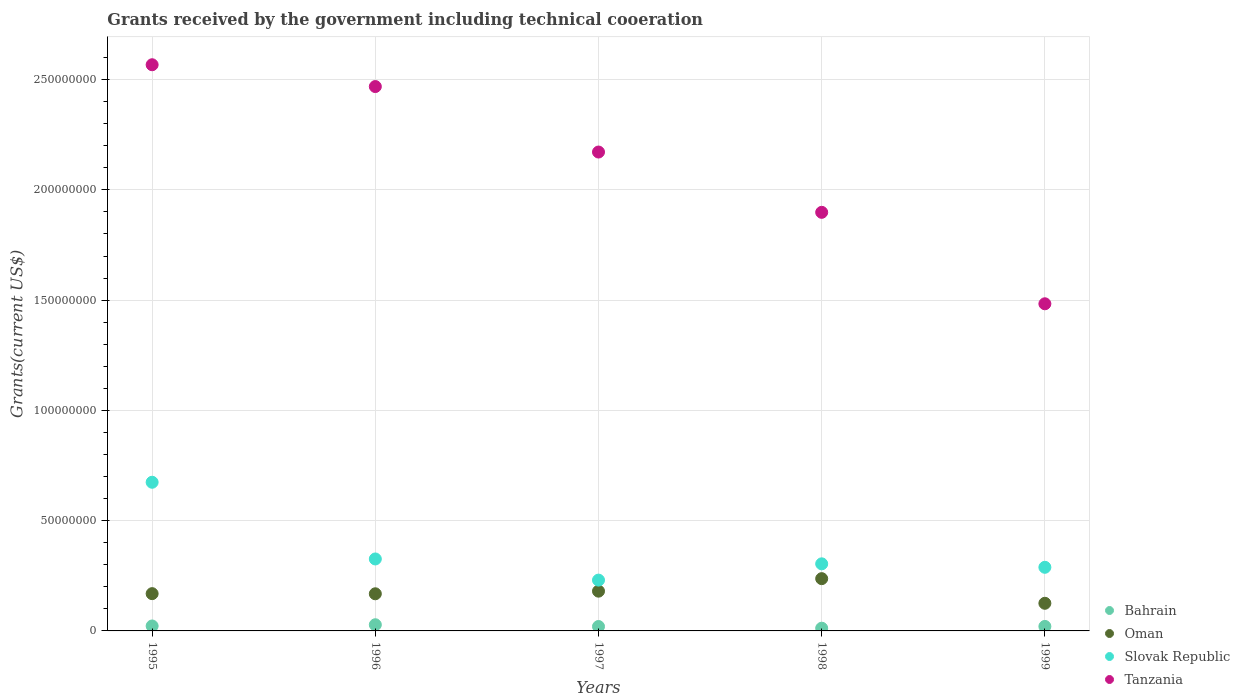Is the number of dotlines equal to the number of legend labels?
Offer a terse response. Yes. What is the total grants received by the government in Bahrain in 1996?
Provide a succinct answer. 2.80e+06. Across all years, what is the maximum total grants received by the government in Tanzania?
Keep it short and to the point. 2.57e+08. Across all years, what is the minimum total grants received by the government in Slovak Republic?
Offer a terse response. 2.30e+07. What is the total total grants received by the government in Tanzania in the graph?
Keep it short and to the point. 1.06e+09. What is the difference between the total grants received by the government in Slovak Republic in 1995 and that in 1999?
Make the answer very short. 3.86e+07. What is the difference between the total grants received by the government in Oman in 1998 and the total grants received by the government in Slovak Republic in 1999?
Provide a short and direct response. -5.15e+06. What is the average total grants received by the government in Oman per year?
Provide a succinct answer. 1.76e+07. In the year 1997, what is the difference between the total grants received by the government in Bahrain and total grants received by the government in Oman?
Your response must be concise. -1.60e+07. What is the ratio of the total grants received by the government in Oman in 1995 to that in 1998?
Your response must be concise. 0.71. Is the total grants received by the government in Slovak Republic in 1996 less than that in 1998?
Your answer should be compact. No. Is the difference between the total grants received by the government in Bahrain in 1996 and 1999 greater than the difference between the total grants received by the government in Oman in 1996 and 1999?
Keep it short and to the point. No. What is the difference between the highest and the second highest total grants received by the government in Tanzania?
Offer a very short reply. 9.89e+06. What is the difference between the highest and the lowest total grants received by the government in Slovak Republic?
Offer a very short reply. 4.44e+07. Is it the case that in every year, the sum of the total grants received by the government in Bahrain and total grants received by the government in Slovak Republic  is greater than the sum of total grants received by the government in Oman and total grants received by the government in Tanzania?
Offer a very short reply. No. Is it the case that in every year, the sum of the total grants received by the government in Oman and total grants received by the government in Slovak Republic  is greater than the total grants received by the government in Tanzania?
Offer a terse response. No. Is the total grants received by the government in Oman strictly less than the total grants received by the government in Slovak Republic over the years?
Offer a very short reply. Yes. How many years are there in the graph?
Keep it short and to the point. 5. Does the graph contain grids?
Provide a short and direct response. Yes. How many legend labels are there?
Your response must be concise. 4. How are the legend labels stacked?
Keep it short and to the point. Vertical. What is the title of the graph?
Provide a succinct answer. Grants received by the government including technical cooeration. What is the label or title of the Y-axis?
Provide a succinct answer. Grants(current US$). What is the Grants(current US$) of Bahrain in 1995?
Keep it short and to the point. 2.24e+06. What is the Grants(current US$) of Oman in 1995?
Give a very brief answer. 1.69e+07. What is the Grants(current US$) of Slovak Republic in 1995?
Make the answer very short. 6.74e+07. What is the Grants(current US$) in Tanzania in 1995?
Your answer should be very brief. 2.57e+08. What is the Grants(current US$) in Bahrain in 1996?
Provide a succinct answer. 2.80e+06. What is the Grants(current US$) of Oman in 1996?
Your answer should be very brief. 1.68e+07. What is the Grants(current US$) of Slovak Republic in 1996?
Ensure brevity in your answer.  3.26e+07. What is the Grants(current US$) in Tanzania in 1996?
Keep it short and to the point. 2.47e+08. What is the Grants(current US$) in Bahrain in 1997?
Keep it short and to the point. 2.00e+06. What is the Grants(current US$) of Oman in 1997?
Ensure brevity in your answer.  1.80e+07. What is the Grants(current US$) in Slovak Republic in 1997?
Keep it short and to the point. 2.30e+07. What is the Grants(current US$) of Tanzania in 1997?
Give a very brief answer. 2.17e+08. What is the Grants(current US$) of Bahrain in 1998?
Make the answer very short. 1.23e+06. What is the Grants(current US$) in Oman in 1998?
Your response must be concise. 2.37e+07. What is the Grants(current US$) in Slovak Republic in 1998?
Provide a short and direct response. 3.04e+07. What is the Grants(current US$) of Tanzania in 1998?
Offer a terse response. 1.90e+08. What is the Grants(current US$) of Bahrain in 1999?
Provide a succinct answer. 2.04e+06. What is the Grants(current US$) in Oman in 1999?
Provide a short and direct response. 1.25e+07. What is the Grants(current US$) in Slovak Republic in 1999?
Keep it short and to the point. 2.88e+07. What is the Grants(current US$) in Tanzania in 1999?
Ensure brevity in your answer.  1.48e+08. Across all years, what is the maximum Grants(current US$) of Bahrain?
Give a very brief answer. 2.80e+06. Across all years, what is the maximum Grants(current US$) of Oman?
Provide a short and direct response. 2.37e+07. Across all years, what is the maximum Grants(current US$) in Slovak Republic?
Ensure brevity in your answer.  6.74e+07. Across all years, what is the maximum Grants(current US$) of Tanzania?
Provide a succinct answer. 2.57e+08. Across all years, what is the minimum Grants(current US$) of Bahrain?
Your answer should be compact. 1.23e+06. Across all years, what is the minimum Grants(current US$) of Oman?
Give a very brief answer. 1.25e+07. Across all years, what is the minimum Grants(current US$) of Slovak Republic?
Ensure brevity in your answer.  2.30e+07. Across all years, what is the minimum Grants(current US$) of Tanzania?
Ensure brevity in your answer.  1.48e+08. What is the total Grants(current US$) of Bahrain in the graph?
Your response must be concise. 1.03e+07. What is the total Grants(current US$) in Oman in the graph?
Your answer should be very brief. 8.80e+07. What is the total Grants(current US$) of Slovak Republic in the graph?
Make the answer very short. 1.82e+08. What is the total Grants(current US$) of Tanzania in the graph?
Provide a short and direct response. 1.06e+09. What is the difference between the Grants(current US$) in Bahrain in 1995 and that in 1996?
Offer a terse response. -5.60e+05. What is the difference between the Grants(current US$) of Slovak Republic in 1995 and that in 1996?
Offer a very short reply. 3.48e+07. What is the difference between the Grants(current US$) of Tanzania in 1995 and that in 1996?
Make the answer very short. 9.89e+06. What is the difference between the Grants(current US$) of Bahrain in 1995 and that in 1997?
Provide a short and direct response. 2.40e+05. What is the difference between the Grants(current US$) in Oman in 1995 and that in 1997?
Keep it short and to the point. -1.13e+06. What is the difference between the Grants(current US$) in Slovak Republic in 1995 and that in 1997?
Offer a very short reply. 4.44e+07. What is the difference between the Grants(current US$) of Tanzania in 1995 and that in 1997?
Your answer should be very brief. 3.96e+07. What is the difference between the Grants(current US$) in Bahrain in 1995 and that in 1998?
Provide a short and direct response. 1.01e+06. What is the difference between the Grants(current US$) in Oman in 1995 and that in 1998?
Your answer should be compact. -6.80e+06. What is the difference between the Grants(current US$) in Slovak Republic in 1995 and that in 1998?
Offer a terse response. 3.70e+07. What is the difference between the Grants(current US$) in Tanzania in 1995 and that in 1998?
Make the answer very short. 6.69e+07. What is the difference between the Grants(current US$) of Oman in 1995 and that in 1999?
Give a very brief answer. 4.37e+06. What is the difference between the Grants(current US$) of Slovak Republic in 1995 and that in 1999?
Offer a very short reply. 3.86e+07. What is the difference between the Grants(current US$) in Tanzania in 1995 and that in 1999?
Provide a succinct answer. 1.08e+08. What is the difference between the Grants(current US$) of Oman in 1996 and that in 1997?
Give a very brief answer. -1.19e+06. What is the difference between the Grants(current US$) of Slovak Republic in 1996 and that in 1997?
Provide a short and direct response. 9.59e+06. What is the difference between the Grants(current US$) in Tanzania in 1996 and that in 1997?
Your response must be concise. 2.97e+07. What is the difference between the Grants(current US$) of Bahrain in 1996 and that in 1998?
Offer a terse response. 1.57e+06. What is the difference between the Grants(current US$) in Oman in 1996 and that in 1998?
Offer a very short reply. -6.86e+06. What is the difference between the Grants(current US$) of Slovak Republic in 1996 and that in 1998?
Make the answer very short. 2.21e+06. What is the difference between the Grants(current US$) in Tanzania in 1996 and that in 1998?
Provide a short and direct response. 5.70e+07. What is the difference between the Grants(current US$) in Bahrain in 1996 and that in 1999?
Your answer should be compact. 7.60e+05. What is the difference between the Grants(current US$) in Oman in 1996 and that in 1999?
Make the answer very short. 4.31e+06. What is the difference between the Grants(current US$) in Slovak Republic in 1996 and that in 1999?
Provide a succinct answer. 3.78e+06. What is the difference between the Grants(current US$) in Tanzania in 1996 and that in 1999?
Keep it short and to the point. 9.85e+07. What is the difference between the Grants(current US$) of Bahrain in 1997 and that in 1998?
Offer a terse response. 7.70e+05. What is the difference between the Grants(current US$) in Oman in 1997 and that in 1998?
Ensure brevity in your answer.  -5.67e+06. What is the difference between the Grants(current US$) of Slovak Republic in 1997 and that in 1998?
Offer a very short reply. -7.38e+06. What is the difference between the Grants(current US$) in Tanzania in 1997 and that in 1998?
Provide a succinct answer. 2.73e+07. What is the difference between the Grants(current US$) in Oman in 1997 and that in 1999?
Your response must be concise. 5.50e+06. What is the difference between the Grants(current US$) of Slovak Republic in 1997 and that in 1999?
Ensure brevity in your answer.  -5.81e+06. What is the difference between the Grants(current US$) in Tanzania in 1997 and that in 1999?
Your response must be concise. 6.88e+07. What is the difference between the Grants(current US$) of Bahrain in 1998 and that in 1999?
Your answer should be compact. -8.10e+05. What is the difference between the Grants(current US$) in Oman in 1998 and that in 1999?
Give a very brief answer. 1.12e+07. What is the difference between the Grants(current US$) of Slovak Republic in 1998 and that in 1999?
Provide a succinct answer. 1.57e+06. What is the difference between the Grants(current US$) of Tanzania in 1998 and that in 1999?
Give a very brief answer. 4.15e+07. What is the difference between the Grants(current US$) of Bahrain in 1995 and the Grants(current US$) of Oman in 1996?
Make the answer very short. -1.46e+07. What is the difference between the Grants(current US$) of Bahrain in 1995 and the Grants(current US$) of Slovak Republic in 1996?
Make the answer very short. -3.04e+07. What is the difference between the Grants(current US$) in Bahrain in 1995 and the Grants(current US$) in Tanzania in 1996?
Your answer should be very brief. -2.45e+08. What is the difference between the Grants(current US$) in Oman in 1995 and the Grants(current US$) in Slovak Republic in 1996?
Offer a terse response. -1.57e+07. What is the difference between the Grants(current US$) in Oman in 1995 and the Grants(current US$) in Tanzania in 1996?
Give a very brief answer. -2.30e+08. What is the difference between the Grants(current US$) in Slovak Republic in 1995 and the Grants(current US$) in Tanzania in 1996?
Keep it short and to the point. -1.79e+08. What is the difference between the Grants(current US$) of Bahrain in 1995 and the Grants(current US$) of Oman in 1997?
Provide a succinct answer. -1.58e+07. What is the difference between the Grants(current US$) in Bahrain in 1995 and the Grants(current US$) in Slovak Republic in 1997?
Ensure brevity in your answer.  -2.08e+07. What is the difference between the Grants(current US$) of Bahrain in 1995 and the Grants(current US$) of Tanzania in 1997?
Your answer should be compact. -2.15e+08. What is the difference between the Grants(current US$) of Oman in 1995 and the Grants(current US$) of Slovak Republic in 1997?
Keep it short and to the point. -6.14e+06. What is the difference between the Grants(current US$) in Oman in 1995 and the Grants(current US$) in Tanzania in 1997?
Offer a terse response. -2.00e+08. What is the difference between the Grants(current US$) in Slovak Republic in 1995 and the Grants(current US$) in Tanzania in 1997?
Give a very brief answer. -1.50e+08. What is the difference between the Grants(current US$) in Bahrain in 1995 and the Grants(current US$) in Oman in 1998?
Your answer should be very brief. -2.15e+07. What is the difference between the Grants(current US$) of Bahrain in 1995 and the Grants(current US$) of Slovak Republic in 1998?
Your answer should be compact. -2.82e+07. What is the difference between the Grants(current US$) in Bahrain in 1995 and the Grants(current US$) in Tanzania in 1998?
Your answer should be very brief. -1.88e+08. What is the difference between the Grants(current US$) of Oman in 1995 and the Grants(current US$) of Slovak Republic in 1998?
Provide a succinct answer. -1.35e+07. What is the difference between the Grants(current US$) in Oman in 1995 and the Grants(current US$) in Tanzania in 1998?
Ensure brevity in your answer.  -1.73e+08. What is the difference between the Grants(current US$) of Slovak Republic in 1995 and the Grants(current US$) of Tanzania in 1998?
Provide a succinct answer. -1.22e+08. What is the difference between the Grants(current US$) of Bahrain in 1995 and the Grants(current US$) of Oman in 1999?
Your response must be concise. -1.03e+07. What is the difference between the Grants(current US$) in Bahrain in 1995 and the Grants(current US$) in Slovak Republic in 1999?
Offer a terse response. -2.66e+07. What is the difference between the Grants(current US$) of Bahrain in 1995 and the Grants(current US$) of Tanzania in 1999?
Offer a terse response. -1.46e+08. What is the difference between the Grants(current US$) of Oman in 1995 and the Grants(current US$) of Slovak Republic in 1999?
Keep it short and to the point. -1.20e+07. What is the difference between the Grants(current US$) of Oman in 1995 and the Grants(current US$) of Tanzania in 1999?
Provide a succinct answer. -1.31e+08. What is the difference between the Grants(current US$) in Slovak Republic in 1995 and the Grants(current US$) in Tanzania in 1999?
Provide a succinct answer. -8.09e+07. What is the difference between the Grants(current US$) of Bahrain in 1996 and the Grants(current US$) of Oman in 1997?
Make the answer very short. -1.52e+07. What is the difference between the Grants(current US$) in Bahrain in 1996 and the Grants(current US$) in Slovak Republic in 1997?
Ensure brevity in your answer.  -2.02e+07. What is the difference between the Grants(current US$) of Bahrain in 1996 and the Grants(current US$) of Tanzania in 1997?
Give a very brief answer. -2.14e+08. What is the difference between the Grants(current US$) of Oman in 1996 and the Grants(current US$) of Slovak Republic in 1997?
Keep it short and to the point. -6.20e+06. What is the difference between the Grants(current US$) in Oman in 1996 and the Grants(current US$) in Tanzania in 1997?
Your answer should be compact. -2.00e+08. What is the difference between the Grants(current US$) in Slovak Republic in 1996 and the Grants(current US$) in Tanzania in 1997?
Keep it short and to the point. -1.85e+08. What is the difference between the Grants(current US$) of Bahrain in 1996 and the Grants(current US$) of Oman in 1998?
Your answer should be compact. -2.09e+07. What is the difference between the Grants(current US$) in Bahrain in 1996 and the Grants(current US$) in Slovak Republic in 1998?
Your response must be concise. -2.76e+07. What is the difference between the Grants(current US$) in Bahrain in 1996 and the Grants(current US$) in Tanzania in 1998?
Ensure brevity in your answer.  -1.87e+08. What is the difference between the Grants(current US$) in Oman in 1996 and the Grants(current US$) in Slovak Republic in 1998?
Keep it short and to the point. -1.36e+07. What is the difference between the Grants(current US$) in Oman in 1996 and the Grants(current US$) in Tanzania in 1998?
Offer a very short reply. -1.73e+08. What is the difference between the Grants(current US$) in Slovak Republic in 1996 and the Grants(current US$) in Tanzania in 1998?
Give a very brief answer. -1.57e+08. What is the difference between the Grants(current US$) in Bahrain in 1996 and the Grants(current US$) in Oman in 1999?
Provide a short and direct response. -9.73e+06. What is the difference between the Grants(current US$) of Bahrain in 1996 and the Grants(current US$) of Slovak Republic in 1999?
Your response must be concise. -2.60e+07. What is the difference between the Grants(current US$) in Bahrain in 1996 and the Grants(current US$) in Tanzania in 1999?
Your answer should be compact. -1.46e+08. What is the difference between the Grants(current US$) of Oman in 1996 and the Grants(current US$) of Slovak Republic in 1999?
Offer a terse response. -1.20e+07. What is the difference between the Grants(current US$) in Oman in 1996 and the Grants(current US$) in Tanzania in 1999?
Your answer should be compact. -1.32e+08. What is the difference between the Grants(current US$) of Slovak Republic in 1996 and the Grants(current US$) of Tanzania in 1999?
Offer a very short reply. -1.16e+08. What is the difference between the Grants(current US$) of Bahrain in 1997 and the Grants(current US$) of Oman in 1998?
Your response must be concise. -2.17e+07. What is the difference between the Grants(current US$) in Bahrain in 1997 and the Grants(current US$) in Slovak Republic in 1998?
Give a very brief answer. -2.84e+07. What is the difference between the Grants(current US$) in Bahrain in 1997 and the Grants(current US$) in Tanzania in 1998?
Make the answer very short. -1.88e+08. What is the difference between the Grants(current US$) in Oman in 1997 and the Grants(current US$) in Slovak Republic in 1998?
Provide a succinct answer. -1.24e+07. What is the difference between the Grants(current US$) of Oman in 1997 and the Grants(current US$) of Tanzania in 1998?
Offer a terse response. -1.72e+08. What is the difference between the Grants(current US$) of Slovak Republic in 1997 and the Grants(current US$) of Tanzania in 1998?
Give a very brief answer. -1.67e+08. What is the difference between the Grants(current US$) in Bahrain in 1997 and the Grants(current US$) in Oman in 1999?
Your answer should be very brief. -1.05e+07. What is the difference between the Grants(current US$) of Bahrain in 1997 and the Grants(current US$) of Slovak Republic in 1999?
Make the answer very short. -2.68e+07. What is the difference between the Grants(current US$) in Bahrain in 1997 and the Grants(current US$) in Tanzania in 1999?
Provide a succinct answer. -1.46e+08. What is the difference between the Grants(current US$) in Oman in 1997 and the Grants(current US$) in Slovak Republic in 1999?
Ensure brevity in your answer.  -1.08e+07. What is the difference between the Grants(current US$) of Oman in 1997 and the Grants(current US$) of Tanzania in 1999?
Your response must be concise. -1.30e+08. What is the difference between the Grants(current US$) of Slovak Republic in 1997 and the Grants(current US$) of Tanzania in 1999?
Make the answer very short. -1.25e+08. What is the difference between the Grants(current US$) of Bahrain in 1998 and the Grants(current US$) of Oman in 1999?
Your response must be concise. -1.13e+07. What is the difference between the Grants(current US$) in Bahrain in 1998 and the Grants(current US$) in Slovak Republic in 1999?
Give a very brief answer. -2.76e+07. What is the difference between the Grants(current US$) in Bahrain in 1998 and the Grants(current US$) in Tanzania in 1999?
Provide a short and direct response. -1.47e+08. What is the difference between the Grants(current US$) of Oman in 1998 and the Grants(current US$) of Slovak Republic in 1999?
Provide a short and direct response. -5.15e+06. What is the difference between the Grants(current US$) of Oman in 1998 and the Grants(current US$) of Tanzania in 1999?
Make the answer very short. -1.25e+08. What is the difference between the Grants(current US$) in Slovak Republic in 1998 and the Grants(current US$) in Tanzania in 1999?
Give a very brief answer. -1.18e+08. What is the average Grants(current US$) in Bahrain per year?
Give a very brief answer. 2.06e+06. What is the average Grants(current US$) in Oman per year?
Your answer should be compact. 1.76e+07. What is the average Grants(current US$) in Slovak Republic per year?
Provide a succinct answer. 3.65e+07. What is the average Grants(current US$) of Tanzania per year?
Offer a terse response. 2.12e+08. In the year 1995, what is the difference between the Grants(current US$) of Bahrain and Grants(current US$) of Oman?
Your response must be concise. -1.47e+07. In the year 1995, what is the difference between the Grants(current US$) of Bahrain and Grants(current US$) of Slovak Republic?
Offer a very short reply. -6.52e+07. In the year 1995, what is the difference between the Grants(current US$) in Bahrain and Grants(current US$) in Tanzania?
Your answer should be very brief. -2.54e+08. In the year 1995, what is the difference between the Grants(current US$) of Oman and Grants(current US$) of Slovak Republic?
Provide a succinct answer. -5.05e+07. In the year 1995, what is the difference between the Grants(current US$) of Oman and Grants(current US$) of Tanzania?
Your answer should be compact. -2.40e+08. In the year 1995, what is the difference between the Grants(current US$) of Slovak Republic and Grants(current US$) of Tanzania?
Your response must be concise. -1.89e+08. In the year 1996, what is the difference between the Grants(current US$) of Bahrain and Grants(current US$) of Oman?
Provide a short and direct response. -1.40e+07. In the year 1996, what is the difference between the Grants(current US$) of Bahrain and Grants(current US$) of Slovak Republic?
Your answer should be compact. -2.98e+07. In the year 1996, what is the difference between the Grants(current US$) in Bahrain and Grants(current US$) in Tanzania?
Provide a short and direct response. -2.44e+08. In the year 1996, what is the difference between the Grants(current US$) in Oman and Grants(current US$) in Slovak Republic?
Your response must be concise. -1.58e+07. In the year 1996, what is the difference between the Grants(current US$) of Oman and Grants(current US$) of Tanzania?
Your answer should be compact. -2.30e+08. In the year 1996, what is the difference between the Grants(current US$) in Slovak Republic and Grants(current US$) in Tanzania?
Your response must be concise. -2.14e+08. In the year 1997, what is the difference between the Grants(current US$) of Bahrain and Grants(current US$) of Oman?
Provide a short and direct response. -1.60e+07. In the year 1997, what is the difference between the Grants(current US$) of Bahrain and Grants(current US$) of Slovak Republic?
Give a very brief answer. -2.10e+07. In the year 1997, what is the difference between the Grants(current US$) in Bahrain and Grants(current US$) in Tanzania?
Provide a short and direct response. -2.15e+08. In the year 1997, what is the difference between the Grants(current US$) in Oman and Grants(current US$) in Slovak Republic?
Provide a succinct answer. -5.01e+06. In the year 1997, what is the difference between the Grants(current US$) of Oman and Grants(current US$) of Tanzania?
Your answer should be very brief. -1.99e+08. In the year 1997, what is the difference between the Grants(current US$) of Slovak Republic and Grants(current US$) of Tanzania?
Provide a short and direct response. -1.94e+08. In the year 1998, what is the difference between the Grants(current US$) of Bahrain and Grants(current US$) of Oman?
Make the answer very short. -2.25e+07. In the year 1998, what is the difference between the Grants(current US$) in Bahrain and Grants(current US$) in Slovak Republic?
Keep it short and to the point. -2.92e+07. In the year 1998, what is the difference between the Grants(current US$) of Bahrain and Grants(current US$) of Tanzania?
Provide a succinct answer. -1.89e+08. In the year 1998, what is the difference between the Grants(current US$) in Oman and Grants(current US$) in Slovak Republic?
Provide a short and direct response. -6.72e+06. In the year 1998, what is the difference between the Grants(current US$) of Oman and Grants(current US$) of Tanzania?
Give a very brief answer. -1.66e+08. In the year 1998, what is the difference between the Grants(current US$) in Slovak Republic and Grants(current US$) in Tanzania?
Provide a short and direct response. -1.59e+08. In the year 1999, what is the difference between the Grants(current US$) in Bahrain and Grants(current US$) in Oman?
Keep it short and to the point. -1.05e+07. In the year 1999, what is the difference between the Grants(current US$) in Bahrain and Grants(current US$) in Slovak Republic?
Keep it short and to the point. -2.68e+07. In the year 1999, what is the difference between the Grants(current US$) in Bahrain and Grants(current US$) in Tanzania?
Give a very brief answer. -1.46e+08. In the year 1999, what is the difference between the Grants(current US$) in Oman and Grants(current US$) in Slovak Republic?
Your answer should be very brief. -1.63e+07. In the year 1999, what is the difference between the Grants(current US$) in Oman and Grants(current US$) in Tanzania?
Offer a terse response. -1.36e+08. In the year 1999, what is the difference between the Grants(current US$) of Slovak Republic and Grants(current US$) of Tanzania?
Make the answer very short. -1.19e+08. What is the ratio of the Grants(current US$) in Bahrain in 1995 to that in 1996?
Give a very brief answer. 0.8. What is the ratio of the Grants(current US$) of Slovak Republic in 1995 to that in 1996?
Keep it short and to the point. 2.07. What is the ratio of the Grants(current US$) in Tanzania in 1995 to that in 1996?
Provide a succinct answer. 1.04. What is the ratio of the Grants(current US$) of Bahrain in 1995 to that in 1997?
Offer a very short reply. 1.12. What is the ratio of the Grants(current US$) of Oman in 1995 to that in 1997?
Offer a very short reply. 0.94. What is the ratio of the Grants(current US$) of Slovak Republic in 1995 to that in 1997?
Your answer should be compact. 2.93. What is the ratio of the Grants(current US$) of Tanzania in 1995 to that in 1997?
Offer a terse response. 1.18. What is the ratio of the Grants(current US$) of Bahrain in 1995 to that in 1998?
Provide a succinct answer. 1.82. What is the ratio of the Grants(current US$) of Oman in 1995 to that in 1998?
Provide a succinct answer. 0.71. What is the ratio of the Grants(current US$) in Slovak Republic in 1995 to that in 1998?
Offer a terse response. 2.22. What is the ratio of the Grants(current US$) in Tanzania in 1995 to that in 1998?
Offer a terse response. 1.35. What is the ratio of the Grants(current US$) in Bahrain in 1995 to that in 1999?
Make the answer very short. 1.1. What is the ratio of the Grants(current US$) of Oman in 1995 to that in 1999?
Offer a terse response. 1.35. What is the ratio of the Grants(current US$) of Slovak Republic in 1995 to that in 1999?
Provide a short and direct response. 2.34. What is the ratio of the Grants(current US$) of Tanzania in 1995 to that in 1999?
Your answer should be compact. 1.73. What is the ratio of the Grants(current US$) of Oman in 1996 to that in 1997?
Keep it short and to the point. 0.93. What is the ratio of the Grants(current US$) of Slovak Republic in 1996 to that in 1997?
Keep it short and to the point. 1.42. What is the ratio of the Grants(current US$) of Tanzania in 1996 to that in 1997?
Your response must be concise. 1.14. What is the ratio of the Grants(current US$) in Bahrain in 1996 to that in 1998?
Ensure brevity in your answer.  2.28. What is the ratio of the Grants(current US$) of Oman in 1996 to that in 1998?
Keep it short and to the point. 0.71. What is the ratio of the Grants(current US$) of Slovak Republic in 1996 to that in 1998?
Your response must be concise. 1.07. What is the ratio of the Grants(current US$) in Tanzania in 1996 to that in 1998?
Your answer should be compact. 1.3. What is the ratio of the Grants(current US$) of Bahrain in 1996 to that in 1999?
Your response must be concise. 1.37. What is the ratio of the Grants(current US$) of Oman in 1996 to that in 1999?
Keep it short and to the point. 1.34. What is the ratio of the Grants(current US$) of Slovak Republic in 1996 to that in 1999?
Provide a short and direct response. 1.13. What is the ratio of the Grants(current US$) in Tanzania in 1996 to that in 1999?
Ensure brevity in your answer.  1.66. What is the ratio of the Grants(current US$) in Bahrain in 1997 to that in 1998?
Give a very brief answer. 1.63. What is the ratio of the Grants(current US$) of Oman in 1997 to that in 1998?
Your answer should be very brief. 0.76. What is the ratio of the Grants(current US$) of Slovak Republic in 1997 to that in 1998?
Your response must be concise. 0.76. What is the ratio of the Grants(current US$) in Tanzania in 1997 to that in 1998?
Ensure brevity in your answer.  1.14. What is the ratio of the Grants(current US$) in Bahrain in 1997 to that in 1999?
Your answer should be very brief. 0.98. What is the ratio of the Grants(current US$) of Oman in 1997 to that in 1999?
Offer a terse response. 1.44. What is the ratio of the Grants(current US$) in Slovak Republic in 1997 to that in 1999?
Keep it short and to the point. 0.8. What is the ratio of the Grants(current US$) of Tanzania in 1997 to that in 1999?
Offer a terse response. 1.46. What is the ratio of the Grants(current US$) of Bahrain in 1998 to that in 1999?
Your answer should be very brief. 0.6. What is the ratio of the Grants(current US$) of Oman in 1998 to that in 1999?
Offer a terse response. 1.89. What is the ratio of the Grants(current US$) of Slovak Republic in 1998 to that in 1999?
Ensure brevity in your answer.  1.05. What is the ratio of the Grants(current US$) of Tanzania in 1998 to that in 1999?
Provide a succinct answer. 1.28. What is the difference between the highest and the second highest Grants(current US$) of Bahrain?
Give a very brief answer. 5.60e+05. What is the difference between the highest and the second highest Grants(current US$) of Oman?
Give a very brief answer. 5.67e+06. What is the difference between the highest and the second highest Grants(current US$) of Slovak Republic?
Your answer should be very brief. 3.48e+07. What is the difference between the highest and the second highest Grants(current US$) in Tanzania?
Offer a terse response. 9.89e+06. What is the difference between the highest and the lowest Grants(current US$) in Bahrain?
Give a very brief answer. 1.57e+06. What is the difference between the highest and the lowest Grants(current US$) of Oman?
Give a very brief answer. 1.12e+07. What is the difference between the highest and the lowest Grants(current US$) in Slovak Republic?
Make the answer very short. 4.44e+07. What is the difference between the highest and the lowest Grants(current US$) of Tanzania?
Your response must be concise. 1.08e+08. 